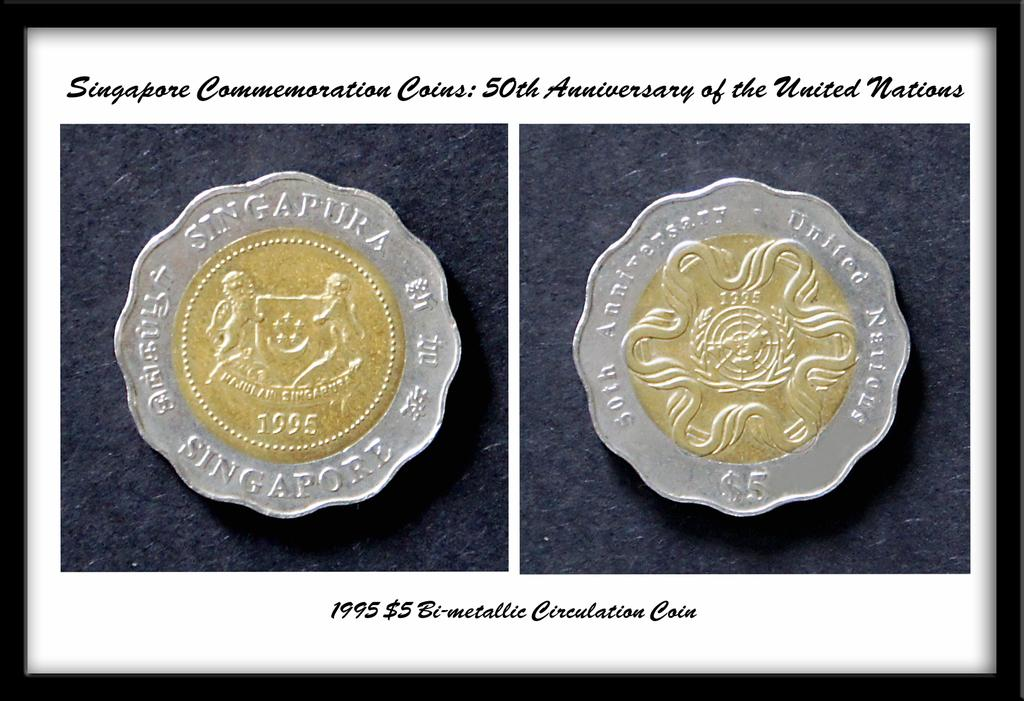<image>
Write a terse but informative summary of the picture. Picture showing a coin with the words "singapura" on top. 